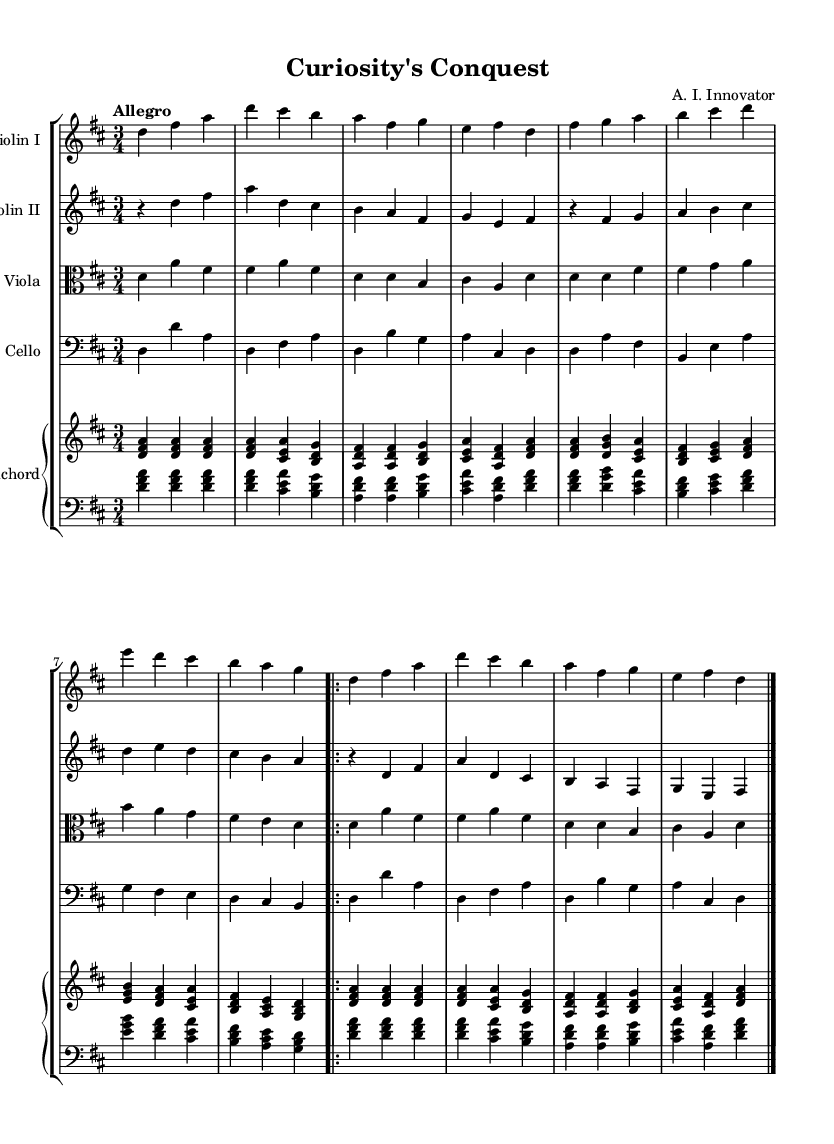What is the key signature of this music? The key signature is indicated in the beginning of the score, showing two sharps (F# and C#), which corresponds to D major.
Answer: D major What is the time signature of this music? The time signature is specified at the beginning of the score, displaying three beats per measure, represented as 3/4.
Answer: 3/4 What is the tempo marking for this piece? The tempo marking "Allegro" is indicated at the beginning, which means to play quickly and lively, giving a clear indication of the desired pace.
Answer: Allegro How many measures are in the first section for Violin I? By counting the measures in the provided section for Violin I, we find that there are eight measures before the repeat sign is reached.
Answer: Eight Which instruments are included in this ensemble? The score lists the instruments at the beginning, identifying Violin I, Violin II, Viola, Cello, and Harpsichord.
Answer: Violin I, Violin II, Viola, Cello, Harpsichord What is the last note of the cello part? The last note in the cello part, before the repeat ending, is a D, as indicated in the last measure.
Answer: D 